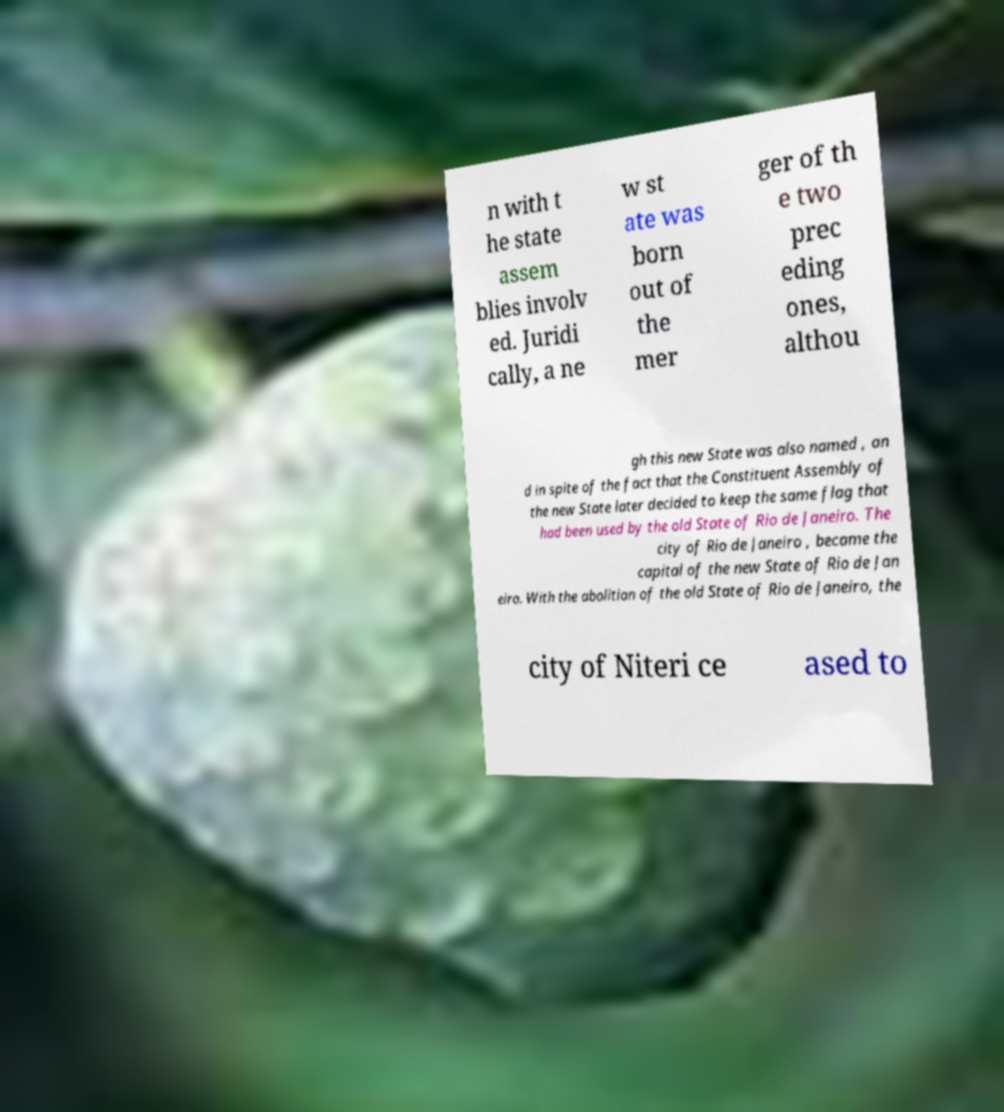What messages or text are displayed in this image? I need them in a readable, typed format. n with t he state assem blies involv ed. Juridi cally, a ne w st ate was born out of the mer ger of th e two prec eding ones, althou gh this new State was also named , an d in spite of the fact that the Constituent Assembly of the new State later decided to keep the same flag that had been used by the old State of Rio de Janeiro. The city of Rio de Janeiro , became the capital of the new State of Rio de Jan eiro. With the abolition of the old State of Rio de Janeiro, the city of Niteri ce ased to 